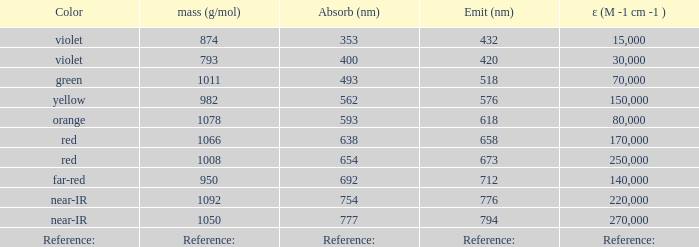Which ε (m -1 cm -1) features a molar mass of 1008 g/mol? 250000.0. 